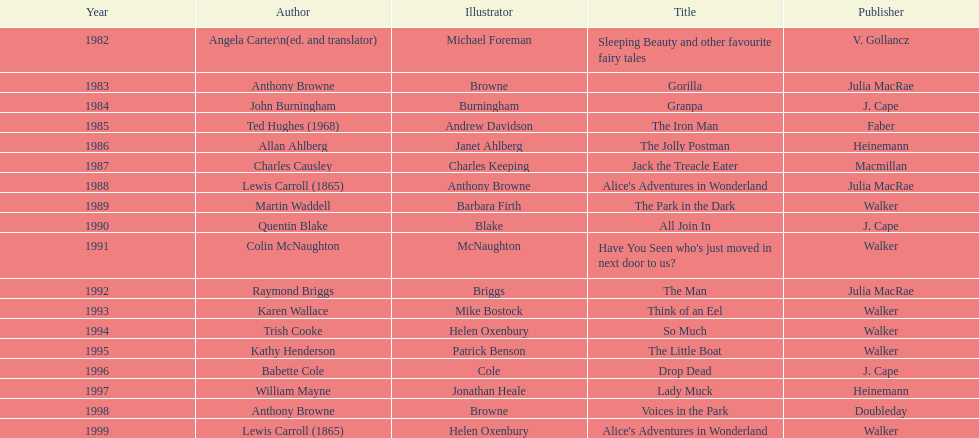Which author composed the foremost award-winning piece? Angela Carter. 